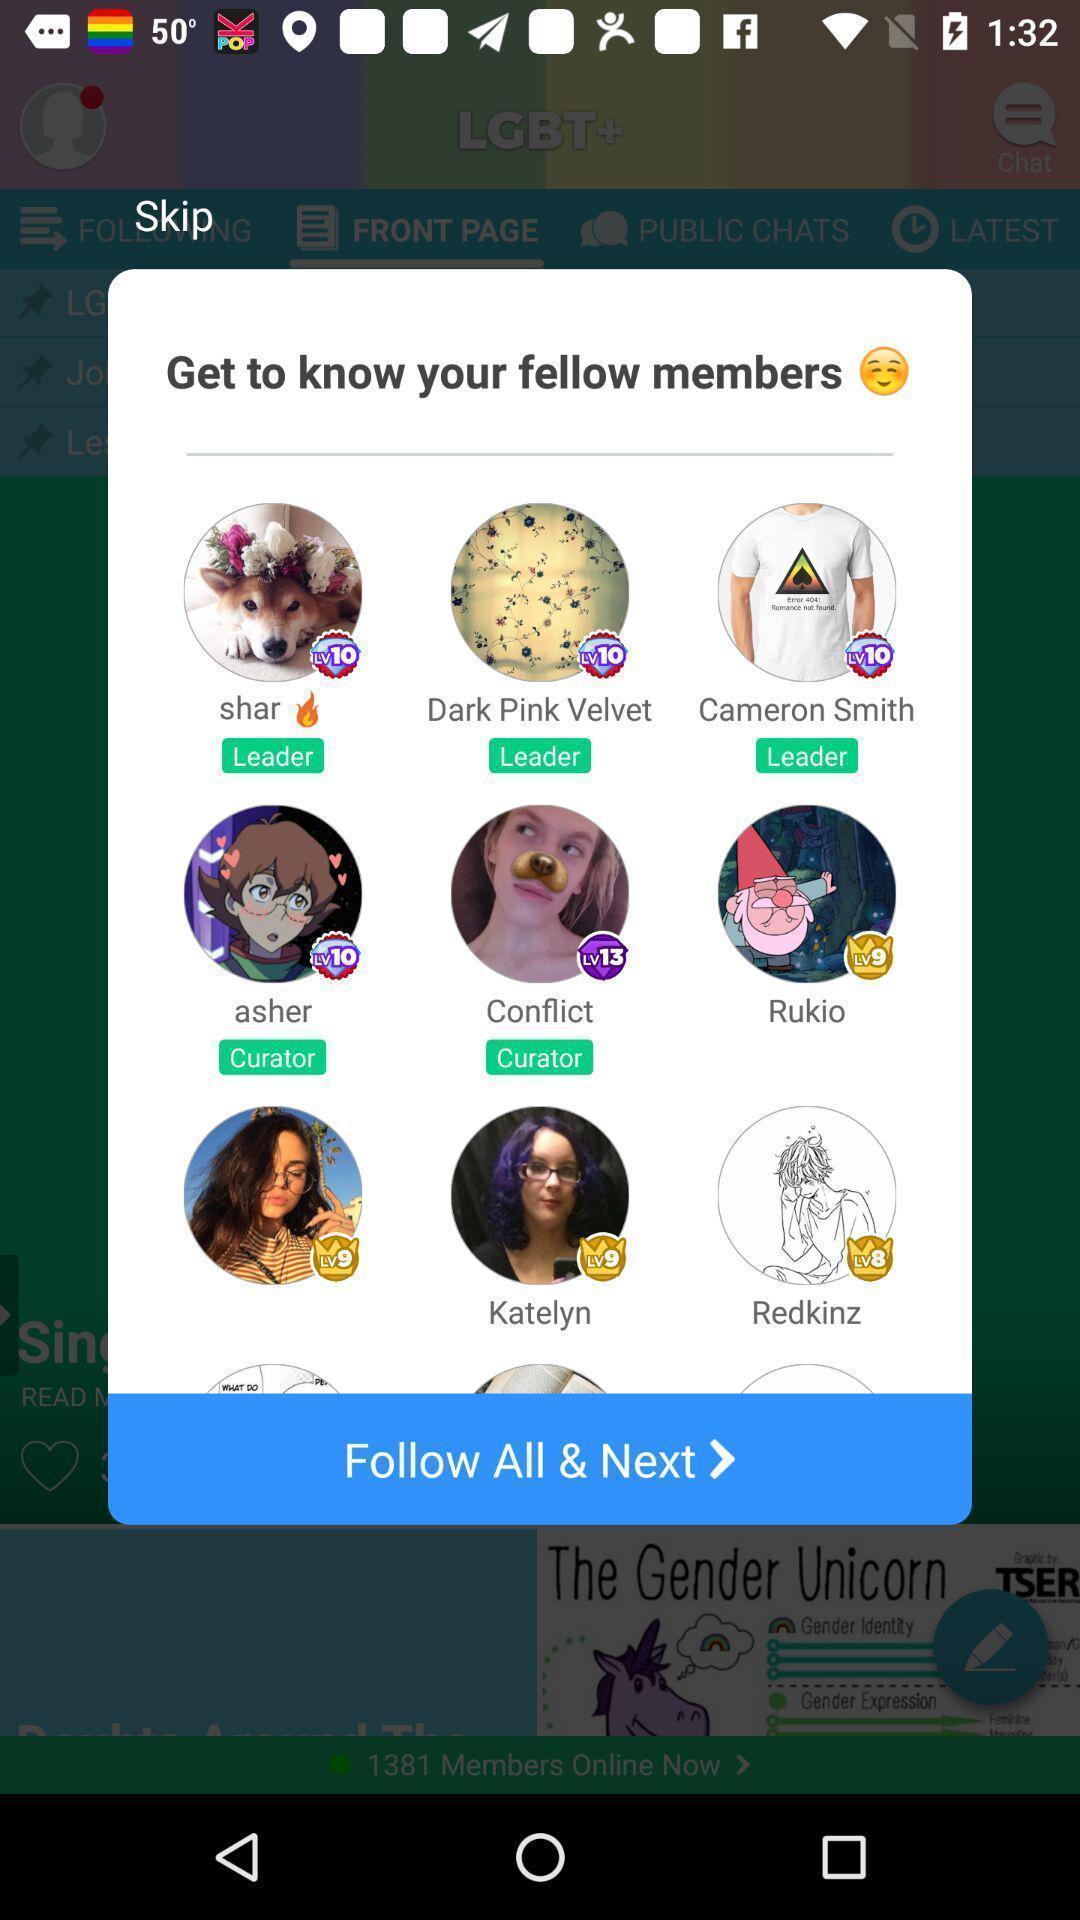Describe the content in this image. Pop-up showing list of profiles on social app. 